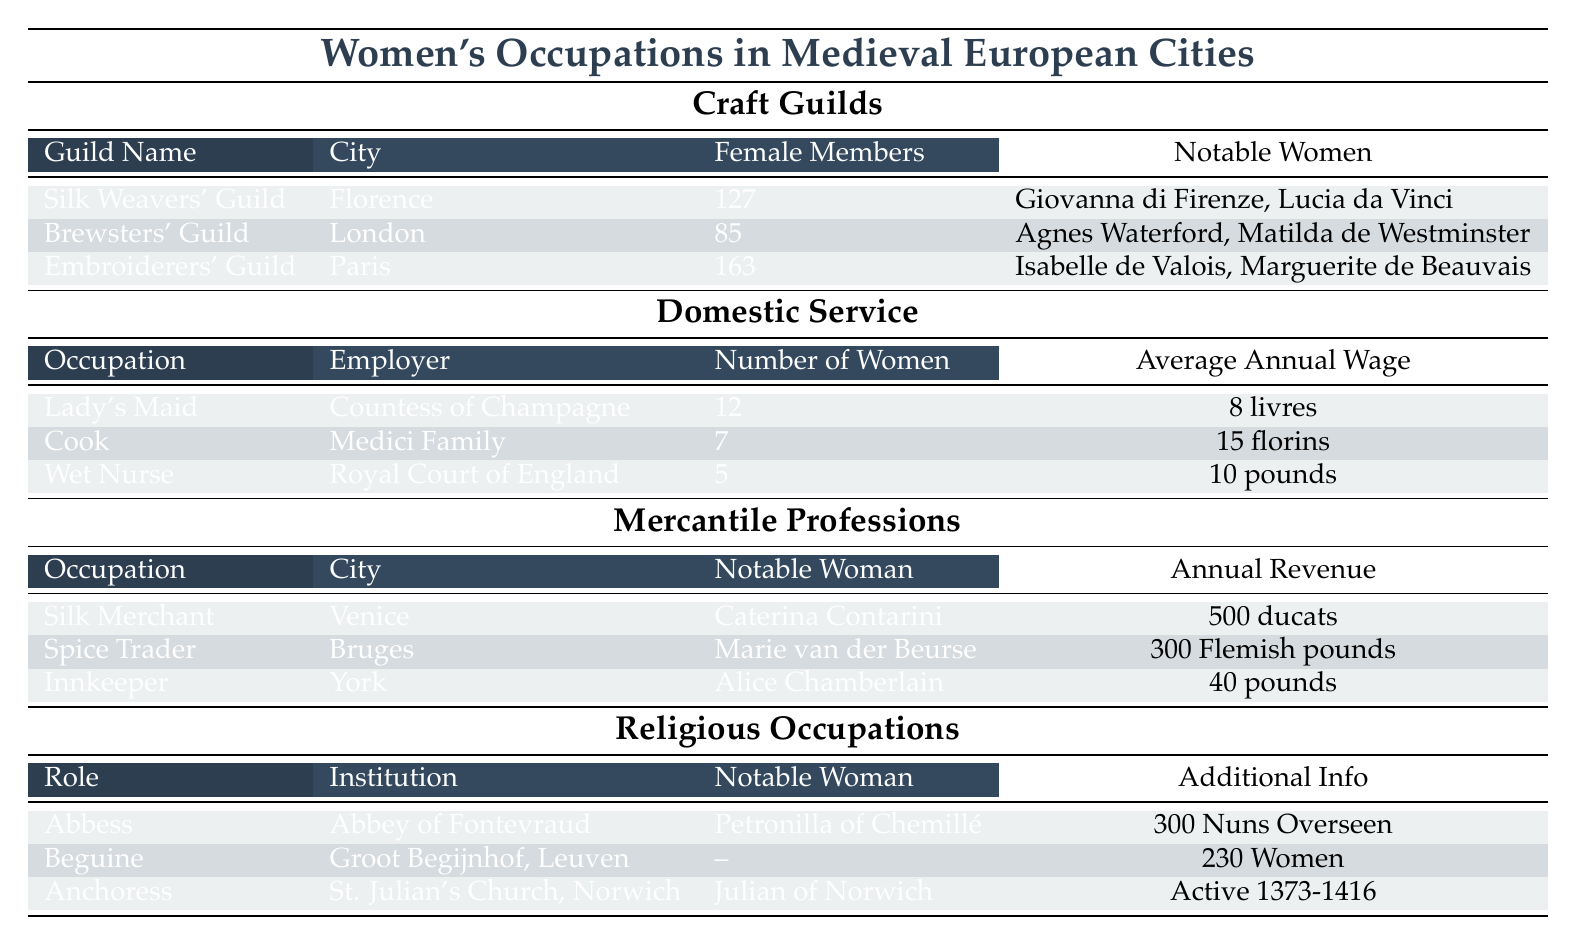What city has the highest number of female members in a craft guild? The table shows three craft guilds and their female members: Silk Weavers' Guild in Florence has 127, Brewsters' Guild in London has 85, and Embroiderers' Guild in Paris has 163. Comparing these numbers, the highest is from the Embroiderers' Guild in Paris.
Answer: Paris How many women were involved in domestic service as a cook? The table lists the Cook occupation under Domestic Service, stating that there were 7 women employed as cooks.
Answer: 7 Which mercantile profession has the highest annual revenue? The table lists three mercantile professions with their respective annual revenues: Silk Merchant in Venice has 500 ducats, Spice Trader in Bruges has 300 Flemish pounds, and Innkeeper in York has 40 pounds. The highest annual revenue is from the Silk Merchant in Venice.
Answer: Silk Merchant What was the average annual wage for a lady's maid? The table states that the average annual wage for a Lady's Maid employed by the Countess of Champagne is 8 livres.
Answer: 8 livres Is there any notable woman associated with the Brewsters' Guild in London? The table provides notable women associated with various guilds. The Brewsters' Guild lists Agnes Waterford and Matilda de Westminster as notable women. Therefore, the answer is yes.
Answer: Yes Which city did Caterina Contarini work in, and what was her profession? The table shows that Caterina Contarini was a Silk Merchant in Venice.
Answer: Venice, Silk Merchant What is the total number of women in domestic service occupations listed in the table? The table lists three domestic service roles: Lady's Maid (12), Cook (7), and Wet Nurse (5). Adding them together, 12 + 7 + 5 equals 24.
Answer: 24 Are there more women in religious occupations or craft guilds? The total number of female members in religious occupations includes 300 nuns overseen by Petronilla of Chemillé, 230 Beguines, and one anchoress, which totals 531. In craft guilds, Silk Weavers' Guild has 127, Brewsters' Guild has 85, and Embroiderers' Guild has 163, totaling 375. Since 531 > 375, there are more women in religious occupations.
Answer: Religious occupations What was the annual revenue of the Spice Trader, and who was the notable woman associated with that profession? The table indicates the Spice Trader earned 300 Flemish pounds and the notable woman associated is Marie van der Beurse.
Answer: 300 Flemish pounds, Marie van der Beurse What percentage of women in the Embroiderers' Guild are notable women? The Embroiderers' Guild has 163 female members and lists two notable women. To find the percentage, 2 notable women / 163 total women * 100 equals approximately 1.23%.
Answer: 1.23% Which religious role is associated with overseeing the most women? The Abbey of Fontevraud has 300 nuns overseen by Abbess Petronilla of Chemillé. This is the highest number compared to the Beguine role with 230 women.
Answer: Abbess 